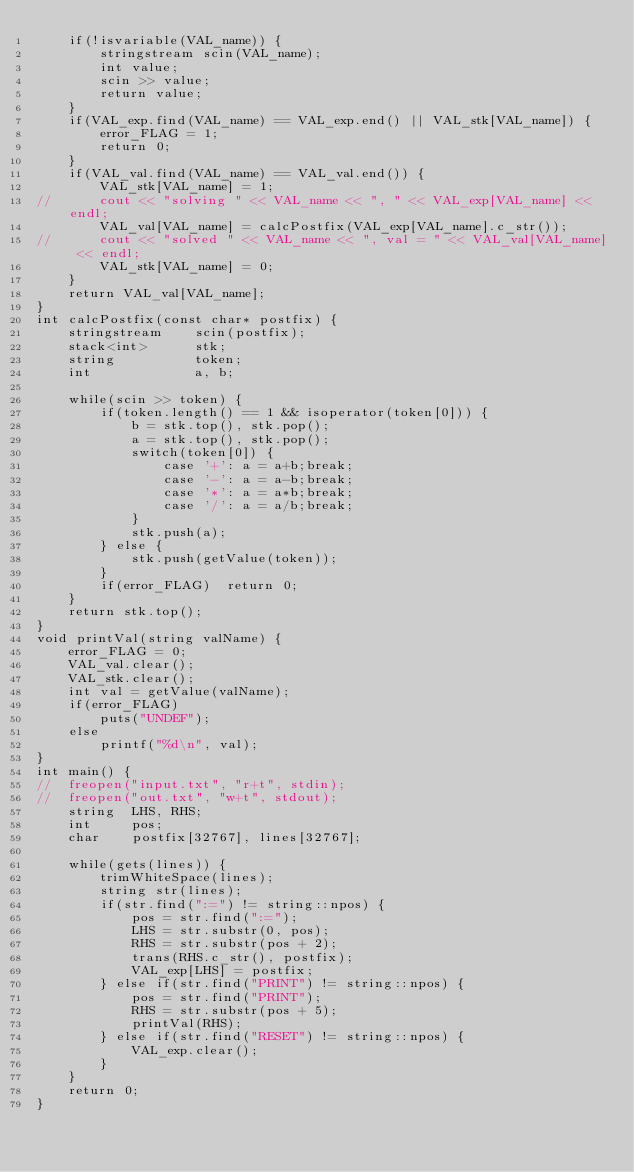<code> <loc_0><loc_0><loc_500><loc_500><_C++_>    if(!isvariable(VAL_name)) {
    	stringstream scin(VAL_name);
    	int value;
    	scin >> value;
    	return value;
    }
	if(VAL_exp.find(VAL_name) == VAL_exp.end() || VAL_stk[VAL_name]) {
		error_FLAG = 1;
		return 0;
	}
	if(VAL_val.find(VAL_name) == VAL_val.end()) {
		VAL_stk[VAL_name] = 1;
//		cout << "solving " << VAL_name << ", " << VAL_exp[VAL_name] << endl; 
		VAL_val[VAL_name] = calcPostfix(VAL_exp[VAL_name].c_str());
//		cout << "solved " << VAL_name << ", val = " << VAL_val[VAL_name] << endl;
		VAL_stk[VAL_name] = 0;
	}
	return VAL_val[VAL_name];
}
int calcPostfix(const char* postfix) {
	stringstream 	scin(postfix);
    stack<int> 		stk;
	string			token;
    int 			a, b;
    
    while(scin >> token) {
    	if(token.length() == 1 && isoperator(token[0])) {
            b = stk.top(), stk.pop();
            a = stk.top(), stk.pop();
            switch(token[0]) {
                case '+': a = a+b;break;
                case '-': a = a-b;break;
                case '*': a = a*b;break;
                case '/': a = a/b;break;
            }
            stk.push(a);
    	} else {
    		stk.push(getValue(token));
    	}
    	if(error_FLAG)	return 0;
    }
    return stk.top();
}
void printVal(string valName) {
	error_FLAG = 0;
	VAL_val.clear();
	VAL_stk.clear();
	int val = getValue(valName);
	if(error_FLAG)
		puts("UNDEF");
	else
		printf("%d\n", val);
}
int main() {
//	freopen("input.txt", "r+t", stdin);
//	freopen("out.txt", "w+t", stdout); 
	string 	LHS, RHS;
	int 	pos;
	char 	postfix[32767], lines[32767];
	
    while(gets(lines)) {
    	trimWhiteSpace(lines);
    	string str(lines);
    	if(str.find(":=") != string::npos) {
    		pos = str.find(":=");
    		LHS = str.substr(0, pos);
    		RHS = str.substr(pos + 2);
    		trans(RHS.c_str(), postfix);
    		VAL_exp[LHS] = postfix;
    	} else if(str.find("PRINT") != string::npos) {
    		pos = str.find("PRINT");
    		RHS = str.substr(pos + 5);
    		printVal(RHS);
    	} else if(str.find("RESET") != string::npos) {
    		VAL_exp.clear();
    	}
    }
    return 0;
}
</code> 